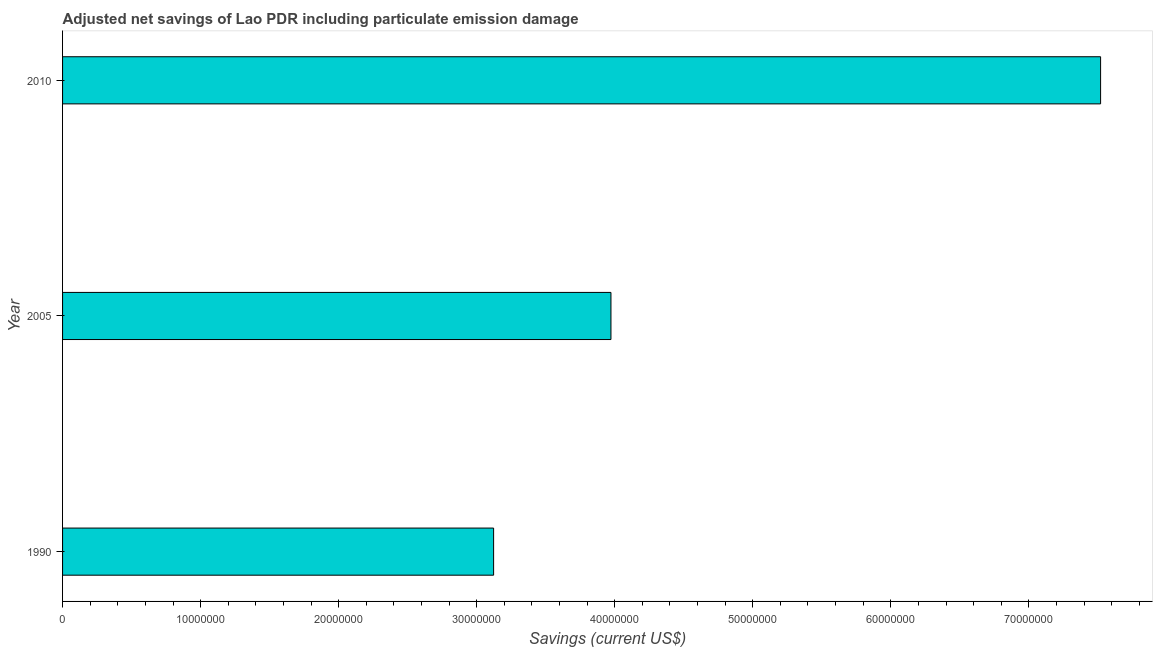Does the graph contain grids?
Provide a succinct answer. No. What is the title of the graph?
Your answer should be compact. Adjusted net savings of Lao PDR including particulate emission damage. What is the label or title of the X-axis?
Provide a short and direct response. Savings (current US$). What is the label or title of the Y-axis?
Your answer should be very brief. Year. What is the adjusted net savings in 1990?
Your answer should be compact. 3.12e+07. Across all years, what is the maximum adjusted net savings?
Your answer should be very brief. 7.52e+07. Across all years, what is the minimum adjusted net savings?
Your response must be concise. 3.12e+07. In which year was the adjusted net savings minimum?
Offer a very short reply. 1990. What is the sum of the adjusted net savings?
Give a very brief answer. 1.46e+08. What is the difference between the adjusted net savings in 2005 and 2010?
Provide a short and direct response. -3.55e+07. What is the average adjusted net savings per year?
Give a very brief answer. 4.87e+07. What is the median adjusted net savings?
Keep it short and to the point. 3.97e+07. In how many years, is the adjusted net savings greater than 64000000 US$?
Your response must be concise. 1. Do a majority of the years between 1990 and 2005 (inclusive) have adjusted net savings greater than 24000000 US$?
Offer a terse response. Yes. What is the ratio of the adjusted net savings in 1990 to that in 2005?
Your answer should be very brief. 0.79. Is the adjusted net savings in 2005 less than that in 2010?
Offer a terse response. Yes. What is the difference between the highest and the second highest adjusted net savings?
Keep it short and to the point. 3.55e+07. What is the difference between the highest and the lowest adjusted net savings?
Ensure brevity in your answer.  4.40e+07. Are all the bars in the graph horizontal?
Make the answer very short. Yes. What is the difference between two consecutive major ticks on the X-axis?
Your answer should be very brief. 1.00e+07. Are the values on the major ticks of X-axis written in scientific E-notation?
Give a very brief answer. No. What is the Savings (current US$) of 1990?
Offer a very short reply. 3.12e+07. What is the Savings (current US$) of 2005?
Your response must be concise. 3.97e+07. What is the Savings (current US$) in 2010?
Your answer should be very brief. 7.52e+07. What is the difference between the Savings (current US$) in 1990 and 2005?
Your answer should be very brief. -8.50e+06. What is the difference between the Savings (current US$) in 1990 and 2010?
Offer a terse response. -4.40e+07. What is the difference between the Savings (current US$) in 2005 and 2010?
Make the answer very short. -3.55e+07. What is the ratio of the Savings (current US$) in 1990 to that in 2005?
Offer a very short reply. 0.79. What is the ratio of the Savings (current US$) in 1990 to that in 2010?
Provide a succinct answer. 0.41. What is the ratio of the Savings (current US$) in 2005 to that in 2010?
Your answer should be very brief. 0.53. 